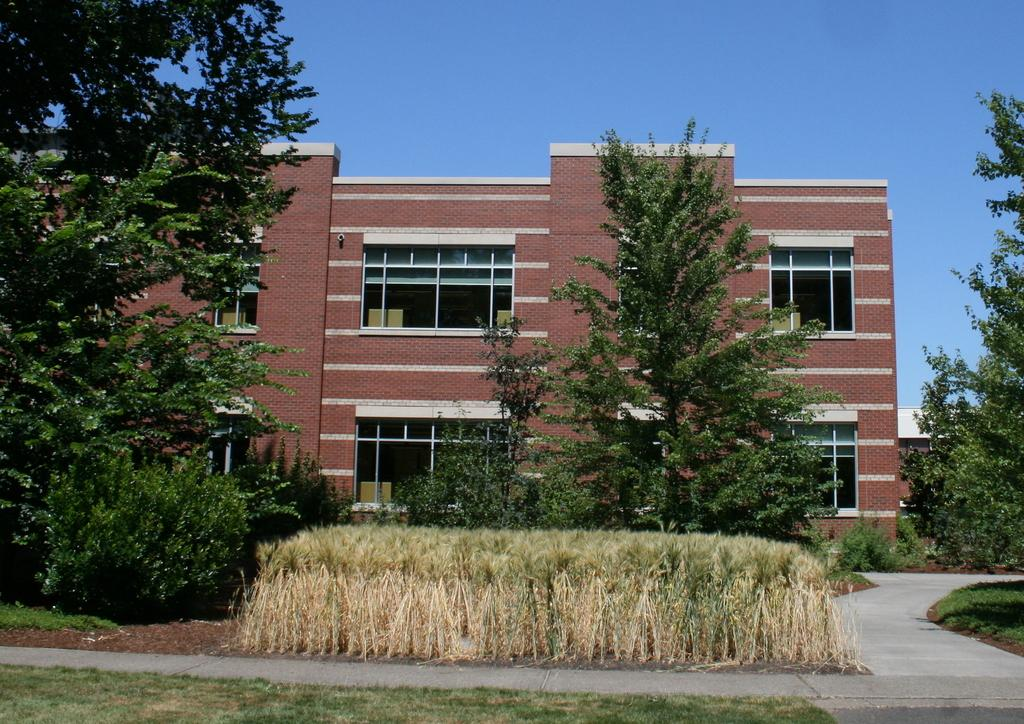What type of vegetation can be seen in the foreground of the image? There is grass and plants in the foreground of the image. What type of surface is visible in the foreground of the image? There is a path in the foreground of the image. What can be seen in the background of the image? There are trees, a pavement, a building, and the sky visible in the background of the image. Can you tell me the history of the receipt in the image? There is no receipt present in the image, so it is not possible to discuss its history. What type of sky is depicted in the image? The sky is visible in the background of the image, but no specific type of sky is mentioned or depicted. 